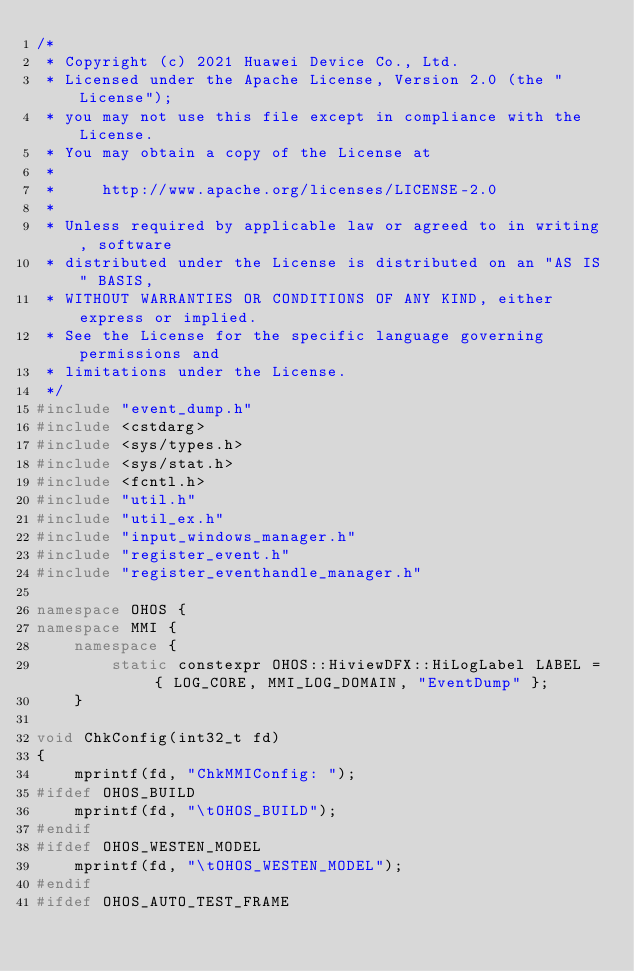<code> <loc_0><loc_0><loc_500><loc_500><_C++_>/*
 * Copyright (c) 2021 Huawei Device Co., Ltd.
 * Licensed under the Apache License, Version 2.0 (the "License");
 * you may not use this file except in compliance with the License.
 * You may obtain a copy of the License at
 *
 *     http://www.apache.org/licenses/LICENSE-2.0
 *
 * Unless required by applicable law or agreed to in writing, software
 * distributed under the License is distributed on an "AS IS" BASIS,
 * WITHOUT WARRANTIES OR CONDITIONS OF ANY KIND, either express or implied.
 * See the License for the specific language governing permissions and
 * limitations under the License.
 */
#include "event_dump.h"
#include <cstdarg>
#include <sys/types.h>
#include <sys/stat.h>
#include <fcntl.h>
#include "util.h"
#include "util_ex.h"
#include "input_windows_manager.h"
#include "register_event.h"
#include "register_eventhandle_manager.h"

namespace OHOS {
namespace MMI {
    namespace {
        static constexpr OHOS::HiviewDFX::HiLogLabel LABEL = { LOG_CORE, MMI_LOG_DOMAIN, "EventDump" };
    }

void ChkConfig(int32_t fd)
{
    mprintf(fd, "ChkMMIConfig: ");
#ifdef OHOS_BUILD
    mprintf(fd, "\tOHOS_BUILD");
#endif
#ifdef OHOS_WESTEN_MODEL
    mprintf(fd, "\tOHOS_WESTEN_MODEL");
#endif
#ifdef OHOS_AUTO_TEST_FRAME</code> 